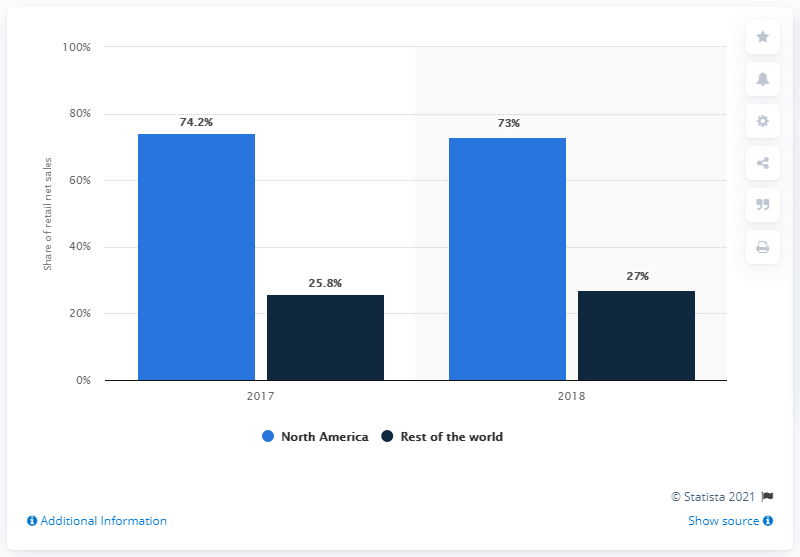Mention a couple of crucial points in this snapshot. In 2020, 73% of Luxottica's retail net sales were generated from North America. 